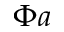Convert formula to latex. <formula><loc_0><loc_0><loc_500><loc_500>\Phi a</formula> 